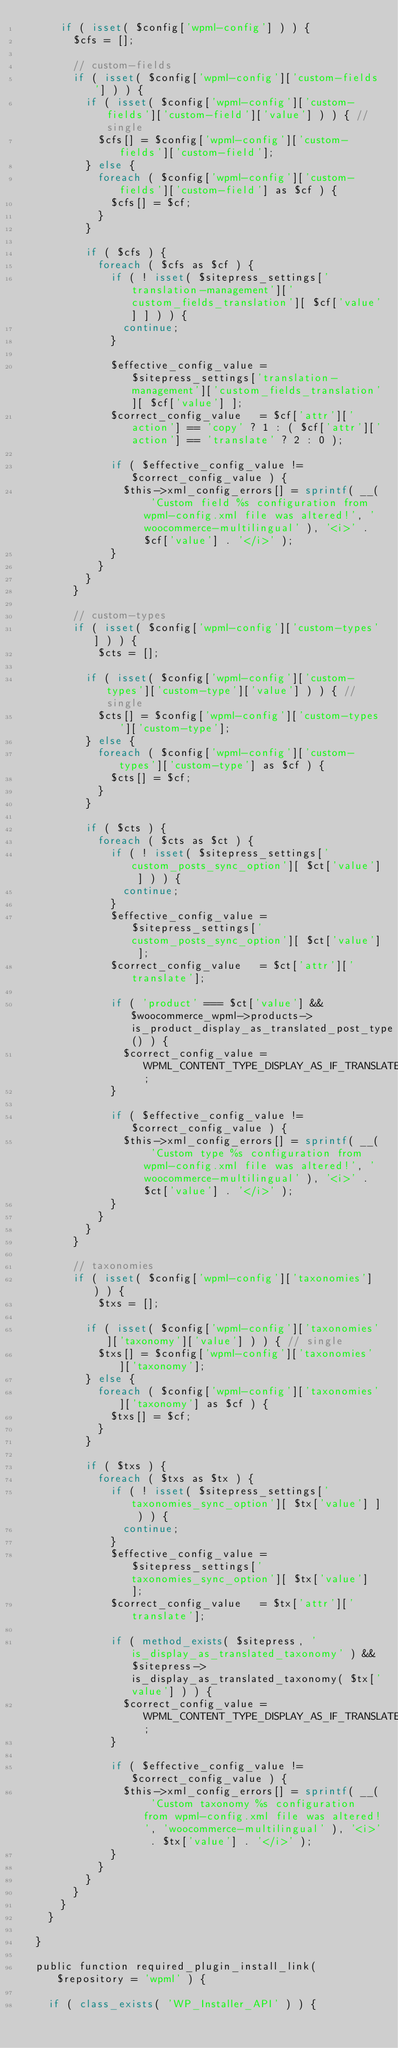Convert code to text. <code><loc_0><loc_0><loc_500><loc_500><_PHP_>			if ( isset( $config['wpml-config'] ) ) {
				$cfs = [];

				// custom-fields
				if ( isset( $config['wpml-config']['custom-fields'] ) ) {
					if ( isset( $config['wpml-config']['custom-fields']['custom-field']['value'] ) ) { // single
						$cfs[] = $config['wpml-config']['custom-fields']['custom-field'];
					} else {
						foreach ( $config['wpml-config']['custom-fields']['custom-field'] as $cf ) {
							$cfs[] = $cf;
						}
					}

					if ( $cfs ) {
						foreach ( $cfs as $cf ) {
							if ( ! isset( $sitepress_settings['translation-management']['custom_fields_translation'][ $cf['value'] ] ) ) {
								continue;
							}

							$effective_config_value = $sitepress_settings['translation-management']['custom_fields_translation'][ $cf['value'] ];
							$correct_config_value   = $cf['attr']['action'] == 'copy' ? 1 : ( $cf['attr']['action'] == 'translate' ? 2 : 0 );

							if ( $effective_config_value != $correct_config_value ) {
								$this->xml_config_errors[] = sprintf( __( 'Custom field %s configuration from wpml-config.xml file was altered!', 'woocommerce-multilingual' ), '<i>' . $cf['value'] . '</i>' );
							}
						}
					}
				}

				// custom-types
				if ( isset( $config['wpml-config']['custom-types'] ) ) {
				    $cts = [];

					if ( isset( $config['wpml-config']['custom-types']['custom-type']['value'] ) ) { // single
						$cts[] = $config['wpml-config']['custom-types']['custom-type'];
					} else {
						foreach ( $config['wpml-config']['custom-types']['custom-type'] as $cf ) {
							$cts[] = $cf;
						}
					}

					if ( $cts ) {
						foreach ( $cts as $ct ) {
							if ( ! isset( $sitepress_settings['custom_posts_sync_option'][ $ct['value'] ] ) ) {
								continue;
							}
							$effective_config_value = $sitepress_settings['custom_posts_sync_option'][ $ct['value'] ];
							$correct_config_value   = $ct['attr']['translate'];

							if ( 'product' === $ct['value'] && $woocommerce_wpml->products->is_product_display_as_translated_post_type() ) {
								$correct_config_value = WPML_CONTENT_TYPE_DISPLAY_AS_IF_TRANSLATED;
							}

							if ( $effective_config_value != $correct_config_value ) {
								$this->xml_config_errors[] = sprintf( __( 'Custom type %s configuration from wpml-config.xml file was altered!', 'woocommerce-multilingual' ), '<i>' . $ct['value'] . '</i>' );
							}
						}
					}
				}

				// taxonomies
				if ( isset( $config['wpml-config']['taxonomies'] ) ) {
				    $txs = [];

					if ( isset( $config['wpml-config']['taxonomies']['taxonomy']['value'] ) ) { // single
						$txs[] = $config['wpml-config']['taxonomies']['taxonomy'];
					} else {
						foreach ( $config['wpml-config']['taxonomies']['taxonomy'] as $cf ) {
							$txs[] = $cf;
						}
					}

					if ( $txs ) {
						foreach ( $txs as $tx ) {
							if ( ! isset( $sitepress_settings['taxonomies_sync_option'][ $tx['value'] ] ) ) {
								continue;
							}
							$effective_config_value = $sitepress_settings['taxonomies_sync_option'][ $tx['value'] ];
							$correct_config_value   = $tx['attr']['translate'];

							if ( method_exists( $sitepress, 'is_display_as_translated_taxonomy' ) && $sitepress->is_display_as_translated_taxonomy( $tx['value'] ) ) {
								$correct_config_value = WPML_CONTENT_TYPE_DISPLAY_AS_IF_TRANSLATED;
							}

							if ( $effective_config_value != $correct_config_value ) {
								$this->xml_config_errors[] = sprintf( __( 'Custom taxonomy %s configuration from wpml-config.xml file was altered!', 'woocommerce-multilingual' ), '<i>' . $tx['value'] . '</i>' );
							}
						}
					}
				}
			}
		}

	}

	public function required_plugin_install_link( $repository = 'wpml' ) {

		if ( class_exists( 'WP_Installer_API' ) ) {</code> 